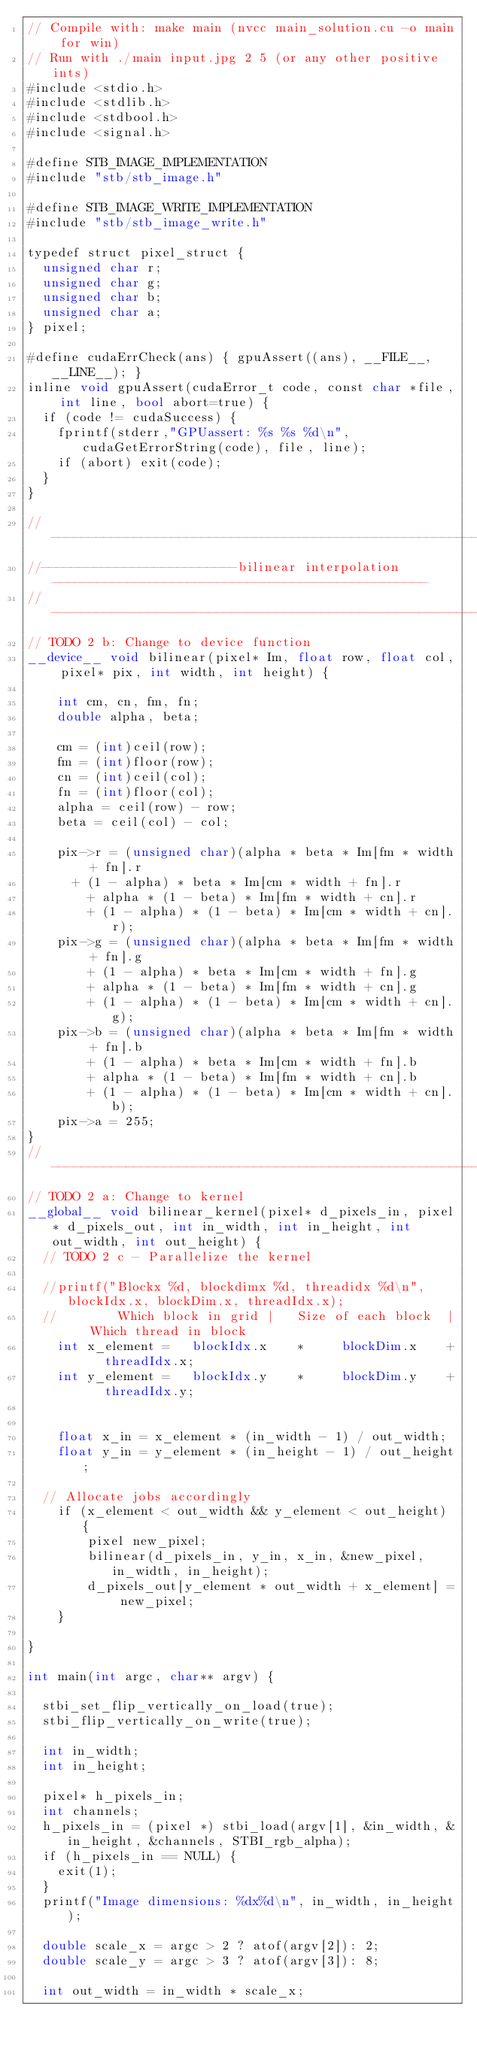Convert code to text. <code><loc_0><loc_0><loc_500><loc_500><_Cuda_>// Compile with: make main (nvcc main_solution.cu -o main for win)
// Run with ./main input.jpg 2 5 (or any other positive ints)
#include <stdio.h>
#include <stdlib.h>
#include <stdbool.h>
#include <signal.h>

#define STB_IMAGE_IMPLEMENTATION
#include "stb/stb_image.h"

#define STB_IMAGE_WRITE_IMPLEMENTATION
#include "stb/stb_image_write.h"

typedef struct pixel_struct {
	unsigned char r;
	unsigned char g;
	unsigned char b;
	unsigned char a;
} pixel;

#define cudaErrCheck(ans) { gpuAssert((ans), __FILE__, __LINE__); }
inline void gpuAssert(cudaError_t code, const char *file, int line, bool abort=true) {
	if (code != cudaSuccess) {
		fprintf(stderr,"GPUassert: %s %s %d\n", cudaGetErrorString(code), file, line);
		if (abort) exit(code);
	}
}

//--------------------------------------------------------------------------------------------------
//--------------------------bilinear interpolation--------------------------------------------------
//--------------------------------------------------------------------------------------------------
// TODO 2 b: Change to device function
__device__ void bilinear(pixel* Im, float row, float col, pixel* pix, int width, int height) {

    int cm, cn, fm, fn;
    double alpha, beta;

    cm = (int)ceil(row);
    fm = (int)floor(row);
    cn = (int)ceil(col);
    fn = (int)floor(col);
    alpha = ceil(row) - row;
    beta = ceil(col) - col;

    pix->r = (unsigned char)(alpha * beta * Im[fm * width + fn].r
    	+ (1 - alpha) * beta * Im[cm * width + fn].r
        + alpha * (1 - beta) * Im[fm * width + cn].r
        + (1 - alpha) * (1 - beta) * Im[cm * width + cn].r);
    pix->g = (unsigned char)(alpha * beta * Im[fm * width + fn].g
        + (1 - alpha) * beta * Im[cm * width + fn].g
        + alpha * (1 - beta) * Im[fm * width + cn].g
        + (1 - alpha) * (1 - beta) * Im[cm * width + cn].g);
    pix->b = (unsigned char)(alpha * beta * Im[fm * width + fn].b
        + (1 - alpha) * beta * Im[cm * width + fn].b
        + alpha * (1 - beta) * Im[fm * width + cn].b
        + (1 - alpha) * (1 - beta) * Im[cm * width + cn].b);
    pix->a = 255;
}
//---------------------------------------------------------------------------
// TODO 2 a: Change to kernel
__global__ void bilinear_kernel(pixel* d_pixels_in, pixel* d_pixels_out, int in_width, int in_height, int out_width, int out_height) {
	// TODO 2 c - Parallelize the kernel
	
	//printf("Blockx %d, blockdimx %d, threadidx %d\n", blockIdx.x, blockDim.x, threadIdx.x);
	// 				Which block in grid	| 	Size of each block	| 	Which thread in block
    int x_element = 	blockIdx.x 		* 		blockDim.x 		+ 	threadIdx.x;
    int y_element = 	blockIdx.y 		* 		blockDim.y 		+ 	threadIdx.y;


    float x_in = x_element * (in_width - 1) / out_width;
    float y_in = y_element * (in_height - 1) / out_height;
	
	// Allocate jobs accordingly
    if (x_element < out_width && y_element < out_height) {
        pixel new_pixel;
        bilinear(d_pixels_in, y_in, x_in, &new_pixel, in_width, in_height);
        d_pixels_out[y_element * out_width + x_element] = new_pixel;
    }
	
}

int main(int argc, char** argv) {

	stbi_set_flip_vertically_on_load(true);
	stbi_flip_vertically_on_write(true);

	int in_width;
	int in_height;

	pixel* h_pixels_in;
	int channels;
	h_pixels_in = (pixel *) stbi_load(argv[1], &in_width, &in_height, &channels, STBI_rgb_alpha);
	if (h_pixels_in == NULL) {
		exit(1);
	}
	printf("Image dimensions: %dx%d\n", in_width, in_height);

	double scale_x = argc > 2 ? atof(argv[2]): 2;
	double scale_y = argc > 3 ? atof(argv[3]): 8;

	int out_width = in_width * scale_x;</code> 